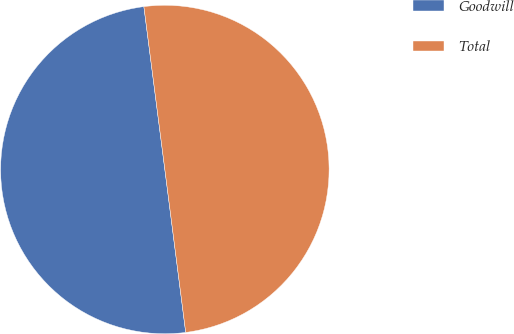<chart> <loc_0><loc_0><loc_500><loc_500><pie_chart><fcel>Goodwill<fcel>Total<nl><fcel>49.99%<fcel>50.01%<nl></chart> 